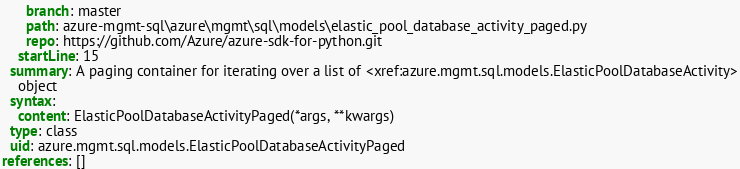<code> <loc_0><loc_0><loc_500><loc_500><_YAML_>      branch: master
      path: azure-mgmt-sql\azure\mgmt\sql\models\elastic_pool_database_activity_paged.py
      repo: https://github.com/Azure/azure-sdk-for-python.git
    startLine: 15
  summary: A paging container for iterating over a list of <xref:azure.mgmt.sql.models.ElasticPoolDatabaseActivity>
    object
  syntax:
    content: ElasticPoolDatabaseActivityPaged(*args, **kwargs)
  type: class
  uid: azure.mgmt.sql.models.ElasticPoolDatabaseActivityPaged
references: []
</code> 